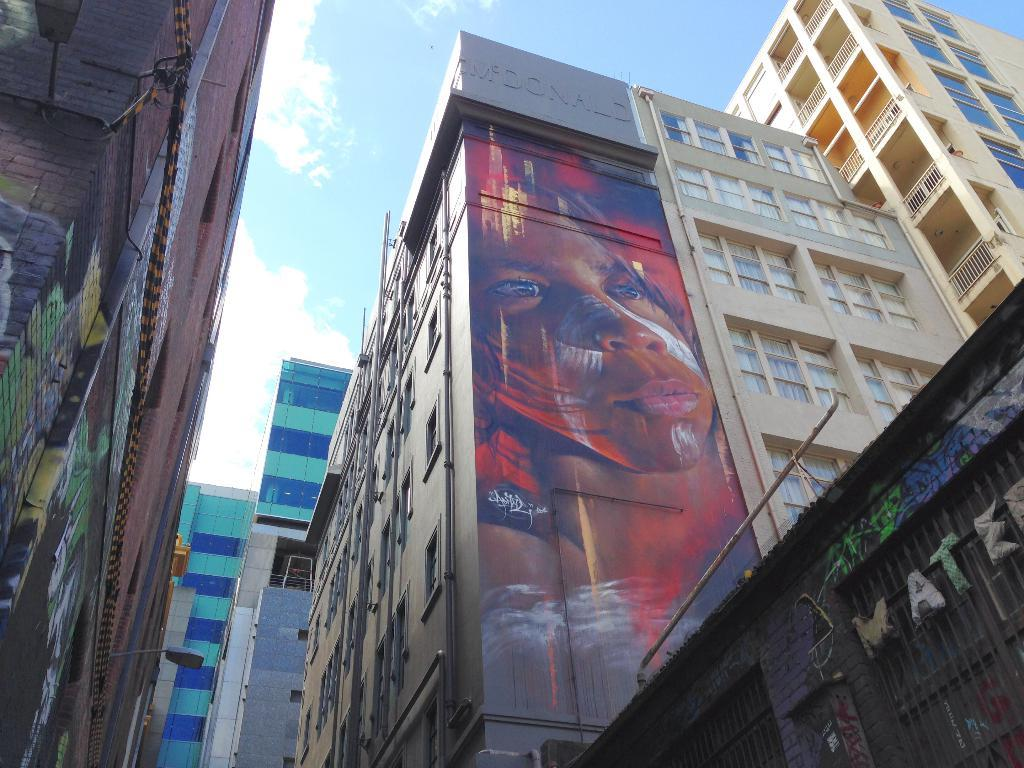What type of structures are visible in the image? There are buildings with windows in the image. What can be seen on the walls of the buildings? The buildings have paintings on their walls. What is visible in the background of the image? Sky is visible in the background of the image. What can be observed in the sky? Clouds are present in the sky. What language is spoken by the creature in the image? There is no creature present in the image, so it is not possible to determine the language spoken by any creature. 